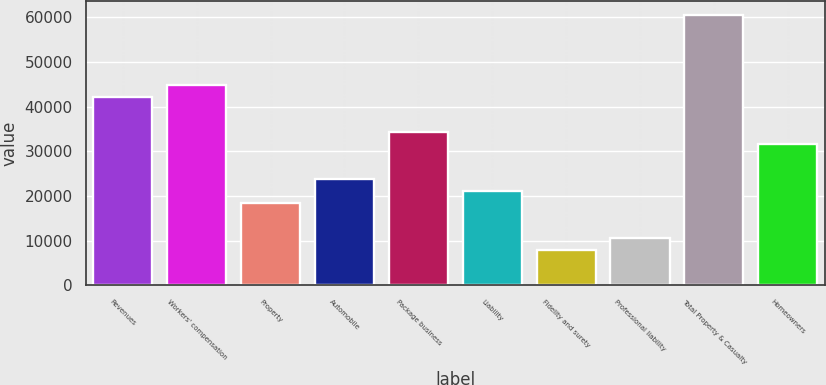Convert chart to OTSL. <chart><loc_0><loc_0><loc_500><loc_500><bar_chart><fcel>Revenues<fcel>Workers' compensation<fcel>Property<fcel>Automobile<fcel>Package business<fcel>Liability<fcel>Fidelity and surety<fcel>Professional liability<fcel>Total Property & Casualty<fcel>Homeowners<nl><fcel>42192<fcel>44822<fcel>18522<fcel>23782<fcel>34302<fcel>21152<fcel>8002<fcel>10632<fcel>60602<fcel>31672<nl></chart> 